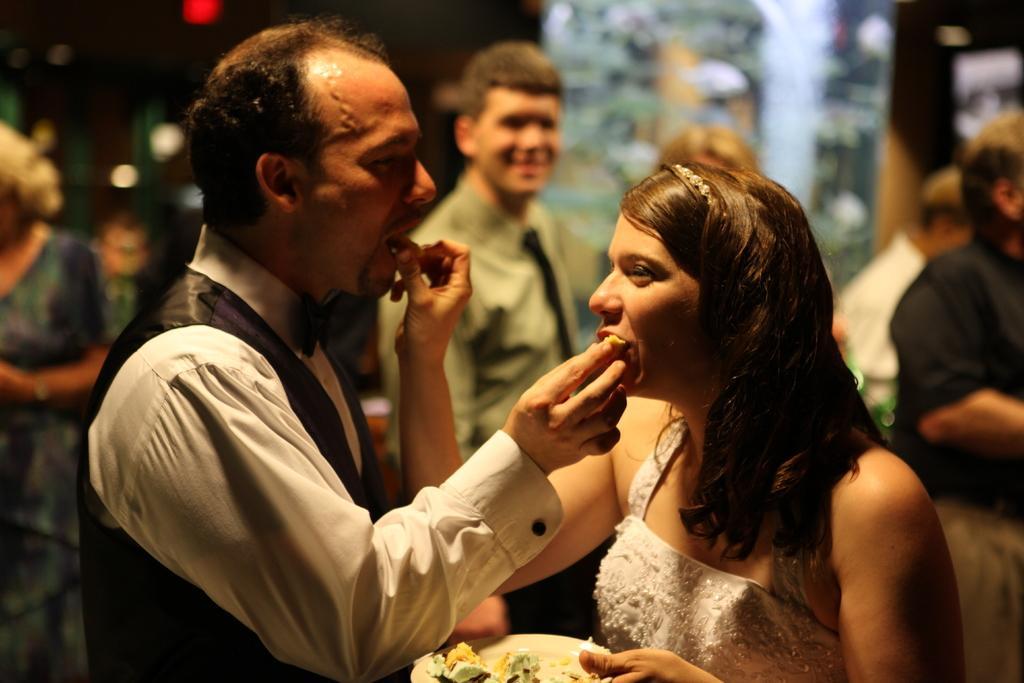How would you summarize this image in a sentence or two? In this image there are two personś eating, there is a person holding a plate,there is a person standing behind the person,there is a person standing towards the right of the image and there is a person standing towards the left of the image. 